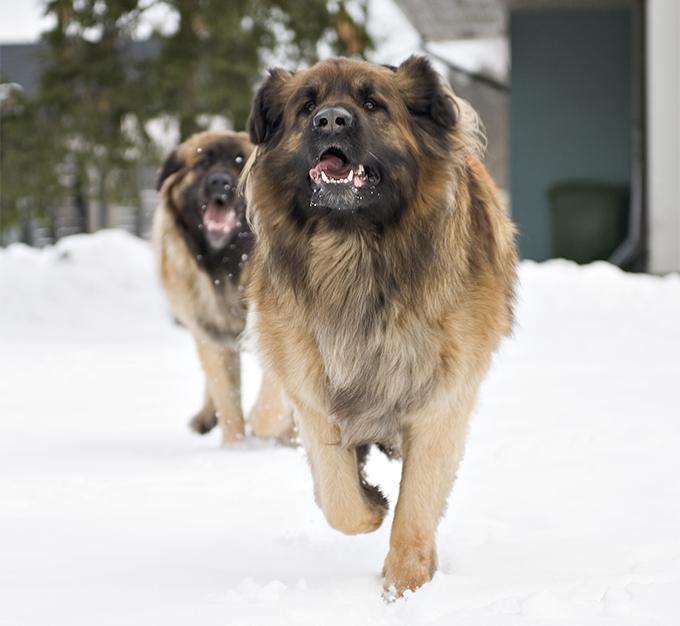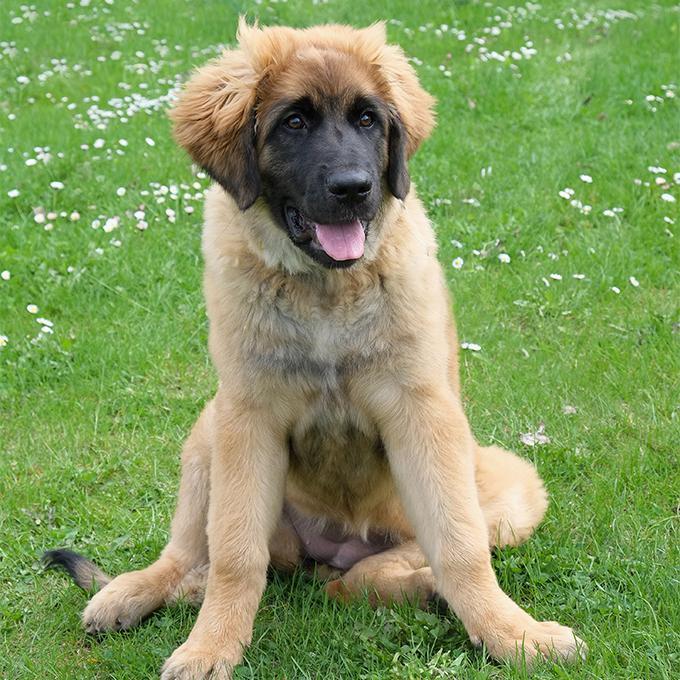The first image is the image on the left, the second image is the image on the right. Given the left and right images, does the statement "One image shows at least one dog on snowy ground." hold true? Answer yes or no. Yes. The first image is the image on the left, the second image is the image on the right. Assess this claim about the two images: "One of the photos shows one or more dogs outside in the snow.". Correct or not? Answer yes or no. Yes. 